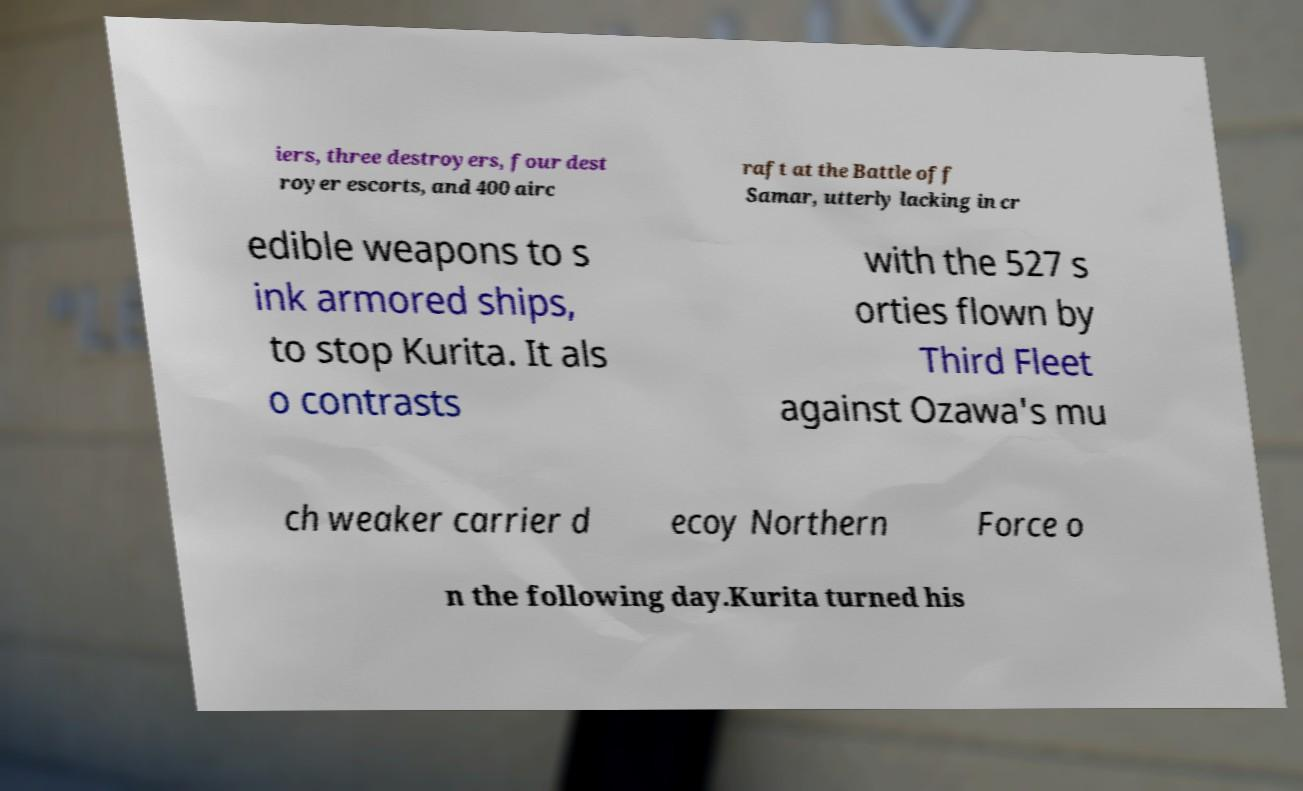Can you read and provide the text displayed in the image?This photo seems to have some interesting text. Can you extract and type it out for me? iers, three destroyers, four dest royer escorts, and 400 airc raft at the Battle off Samar, utterly lacking in cr edible weapons to s ink armored ships, to stop Kurita. It als o contrasts with the 527 s orties flown by Third Fleet against Ozawa's mu ch weaker carrier d ecoy Northern Force o n the following day.Kurita turned his 